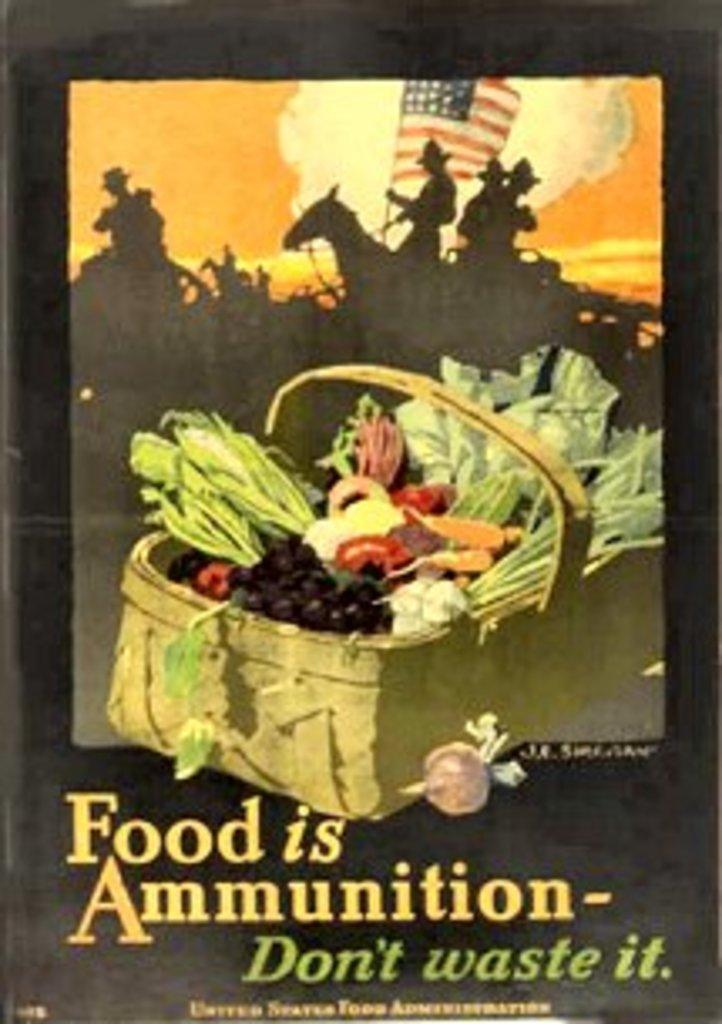<image>
Relay a brief, clear account of the picture shown. A propaganda poster that says Food is Ammunition-Don't waste it. 